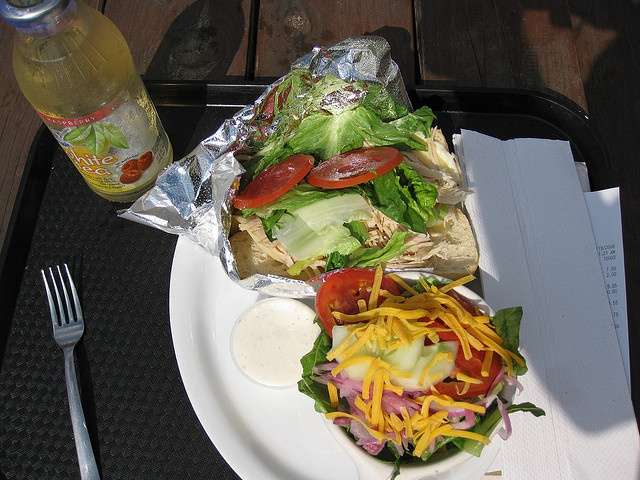Describe the objects in this image and their specific colors. I can see sandwich in blue, olive, and khaki tones, bottle in blue, olive, gray, and maroon tones, and fork in blue, gray, darkgray, and black tones in this image. 